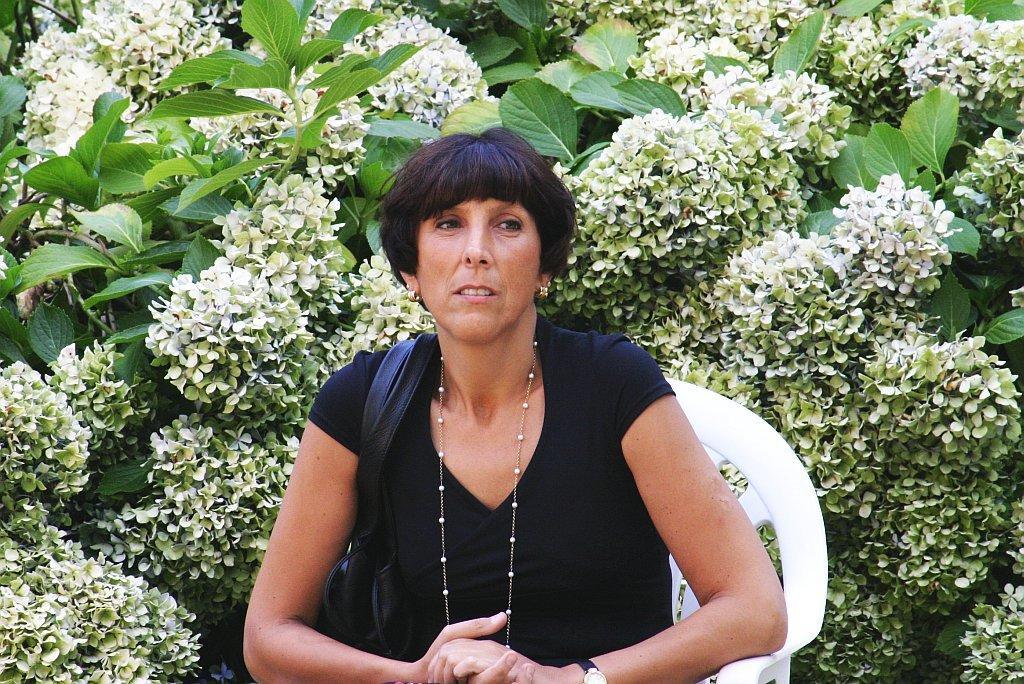Describe this image in one or two sentences. In this picture I can see there is a woman sitting in the white chair and she is wearing a black dress and a black hand bag with a necklace and there are few plants with white flowers in the backdrop. 